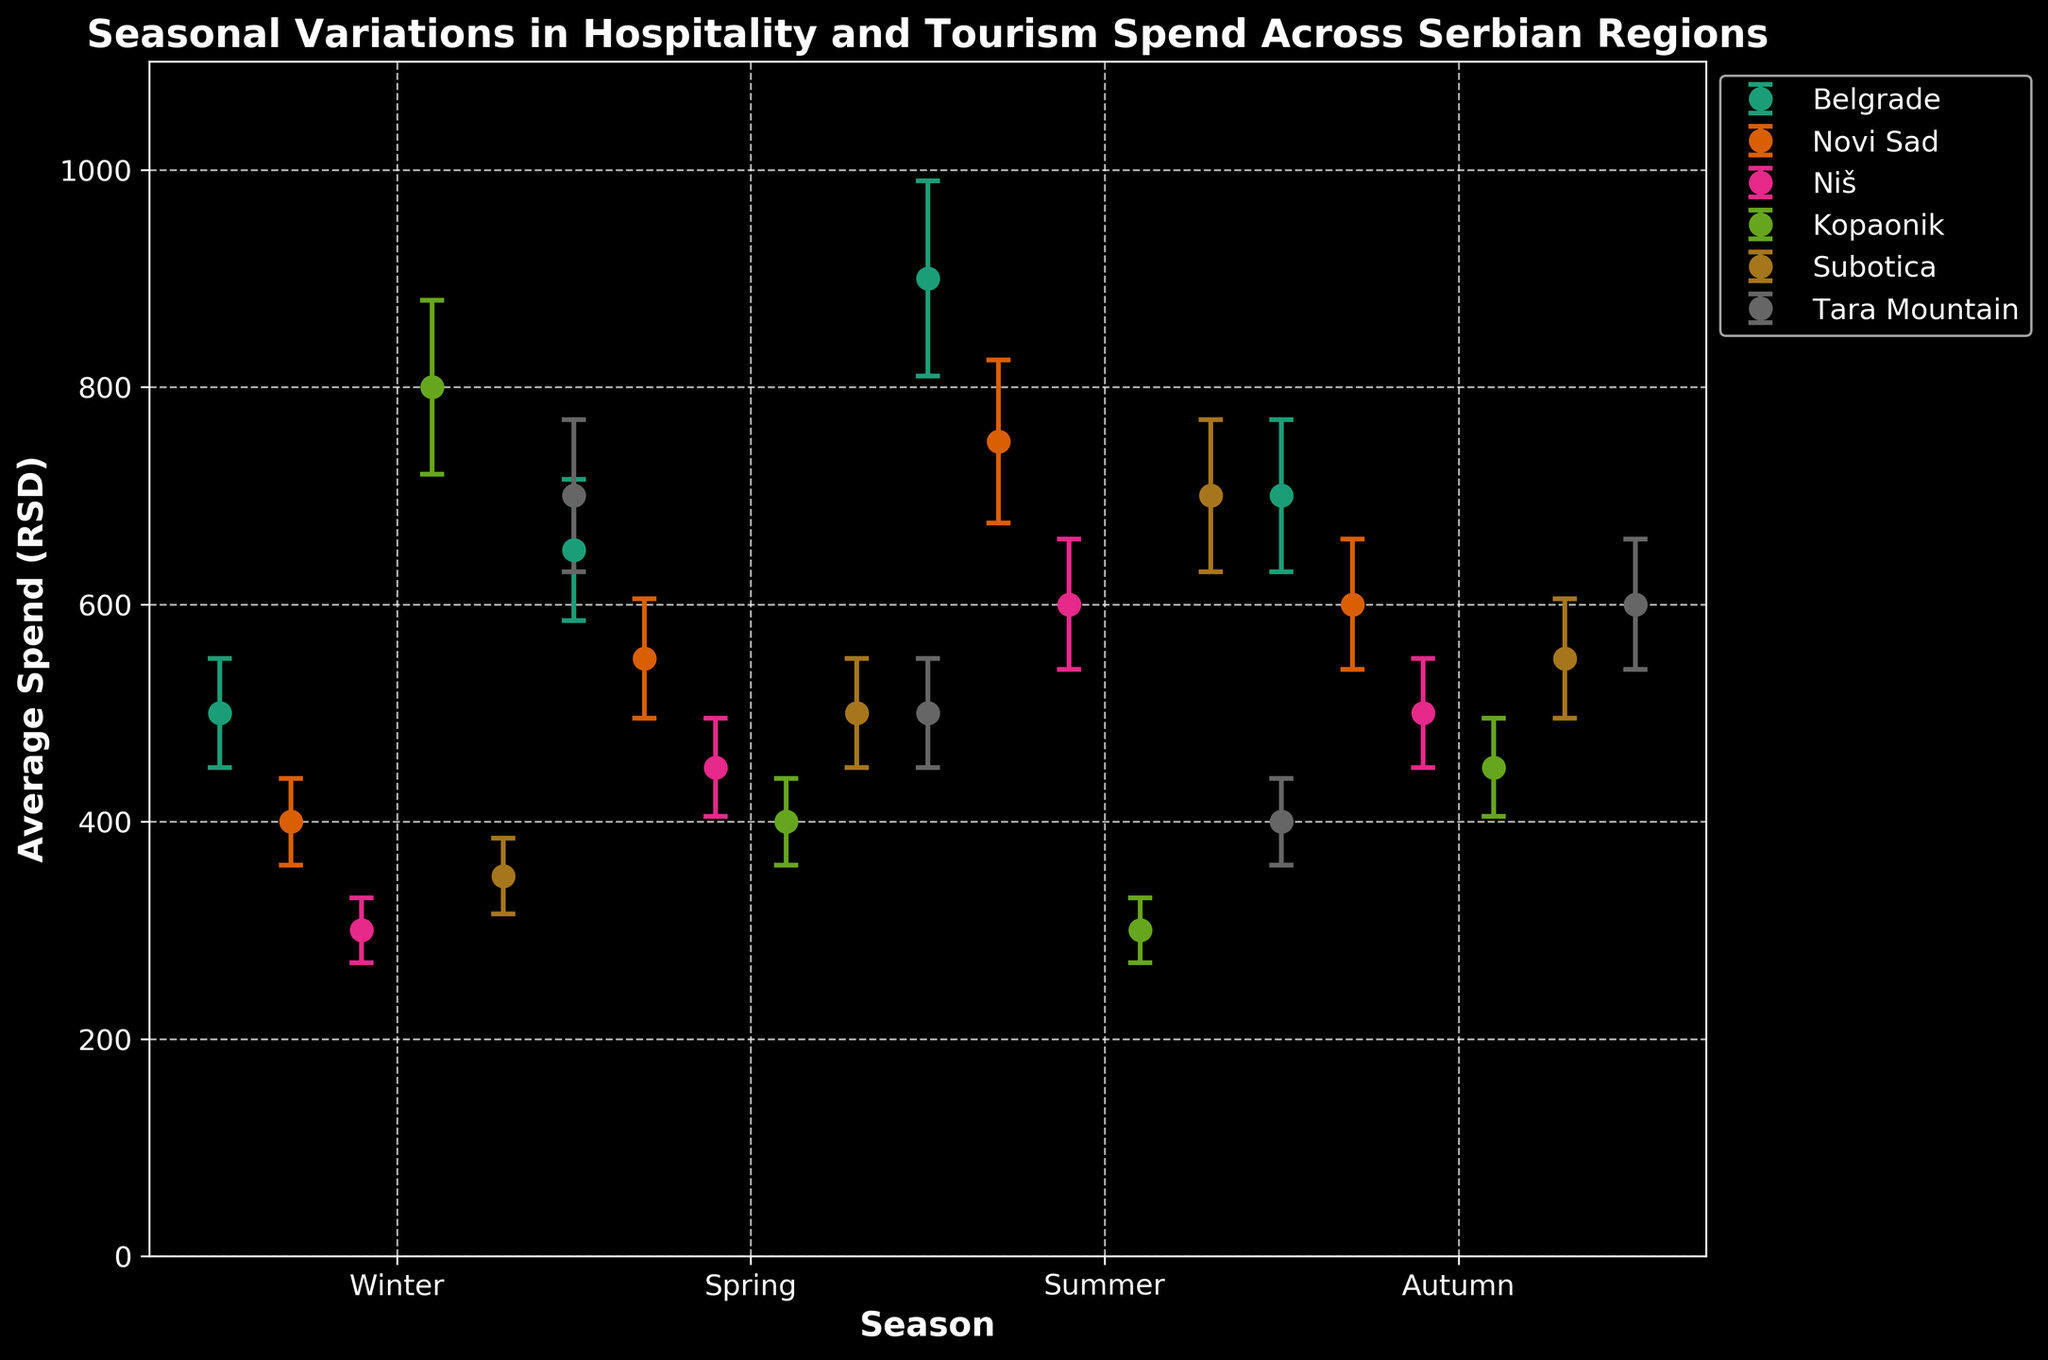What is the title of the figure? The title is usually located at the top of the figure.
Answer: Seasonal Variations in Hospitality and Tourism Spend Across Serbian Regions Which region has the highest average spend during the Summer season? Find the Summer season on the x-axis and identify the highest dot across all regions.
Answer: Belgrade During which season does Kopaonik have the lowest average spend? Find Kopaonik on the legend, then look at the error bars associated with its dots across the seasons.
Answer: Summer Which region shows a decreasing trend in average spend from Winter to Summer? Look across the data points from Winter to Summer for each region to identify any that show a consistent decrease.
Answer: Kopaonik What is the average spend in Belgrade during Autumn? Locate the dot associated with Belgrade during the Autumn season and note its value.
Answer: 700 RSD What is the disparity in average spend between Winter and Summer for Niš? Subtract Niš's Winter spend from its Summer spend. 600 - 300 = 300
Answer: 300 RSD Which region has the largest variation (standard error) in average spend in Summer? Identify the largest error bar in Summer across all regions.
Answer: Belgrade How does Subotica's spend in Spring compare to Tara Mountain's spend in the same season? Compare the value of Subotica's dot in Spring with that of Tara Mountain.
Answer: Subotica's spend is higher Which season shows the least spend variation across all regions? Look for the season where the error bars are relatively short and similar in length across regions.
Answer: Autumn What's the average spend for Novi Sad across all seasons? Add up the spend for Novi Sad for each season and divide by the number of seasons: (400+550+750+600)/4 = 575
Answer: 575 RSD 